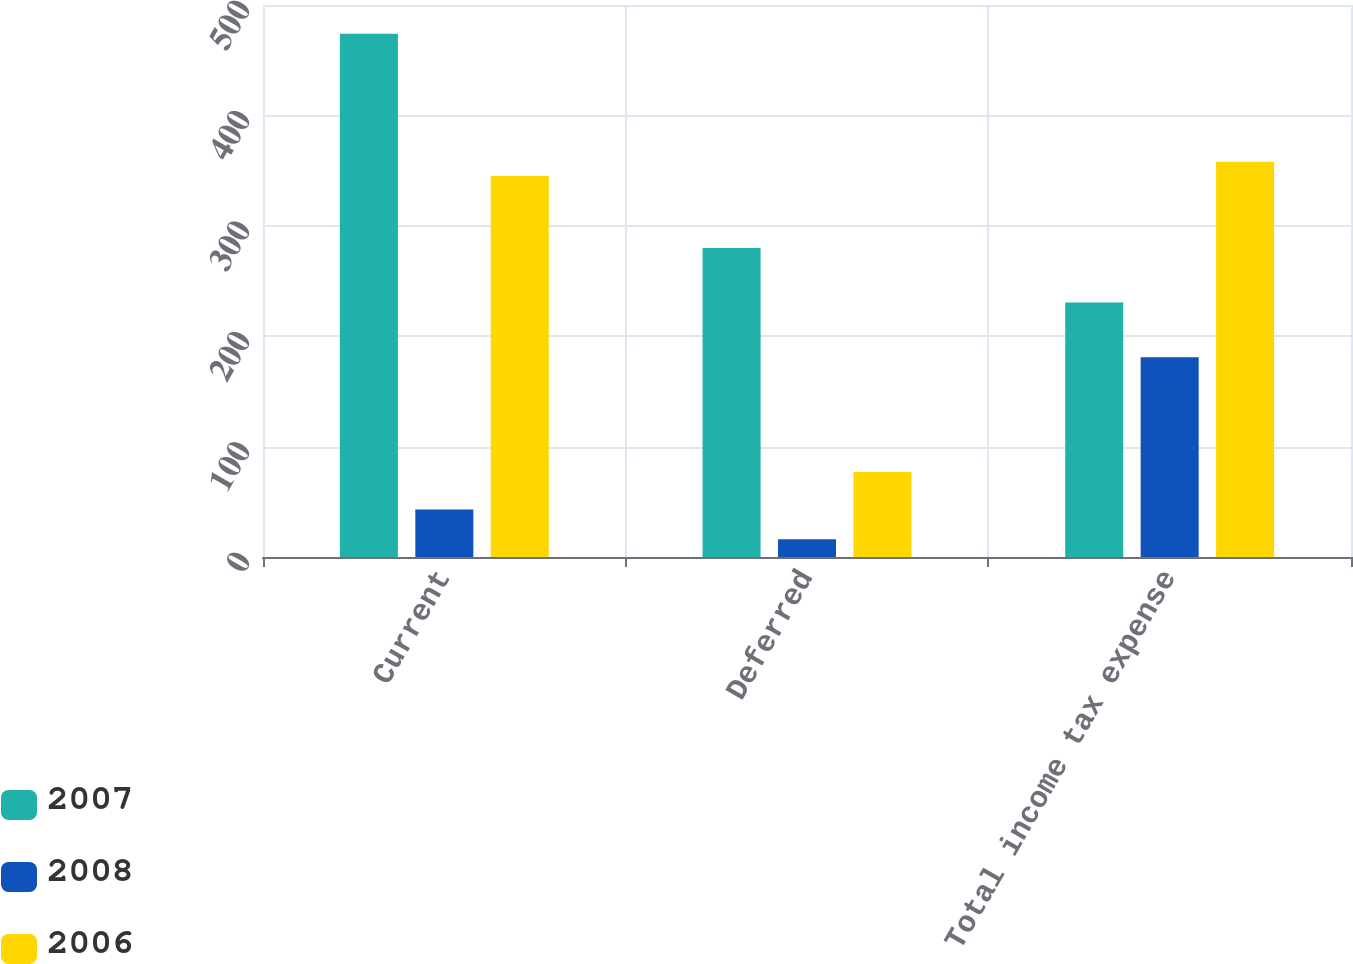Convert chart to OTSL. <chart><loc_0><loc_0><loc_500><loc_500><stacked_bar_chart><ecel><fcel>Current<fcel>Deferred<fcel>Total income tax expense<nl><fcel>2007<fcel>474<fcel>280<fcel>230.5<nl><fcel>2008<fcel>43<fcel>16<fcel>181<nl><fcel>2006<fcel>345<fcel>77<fcel>358<nl></chart> 